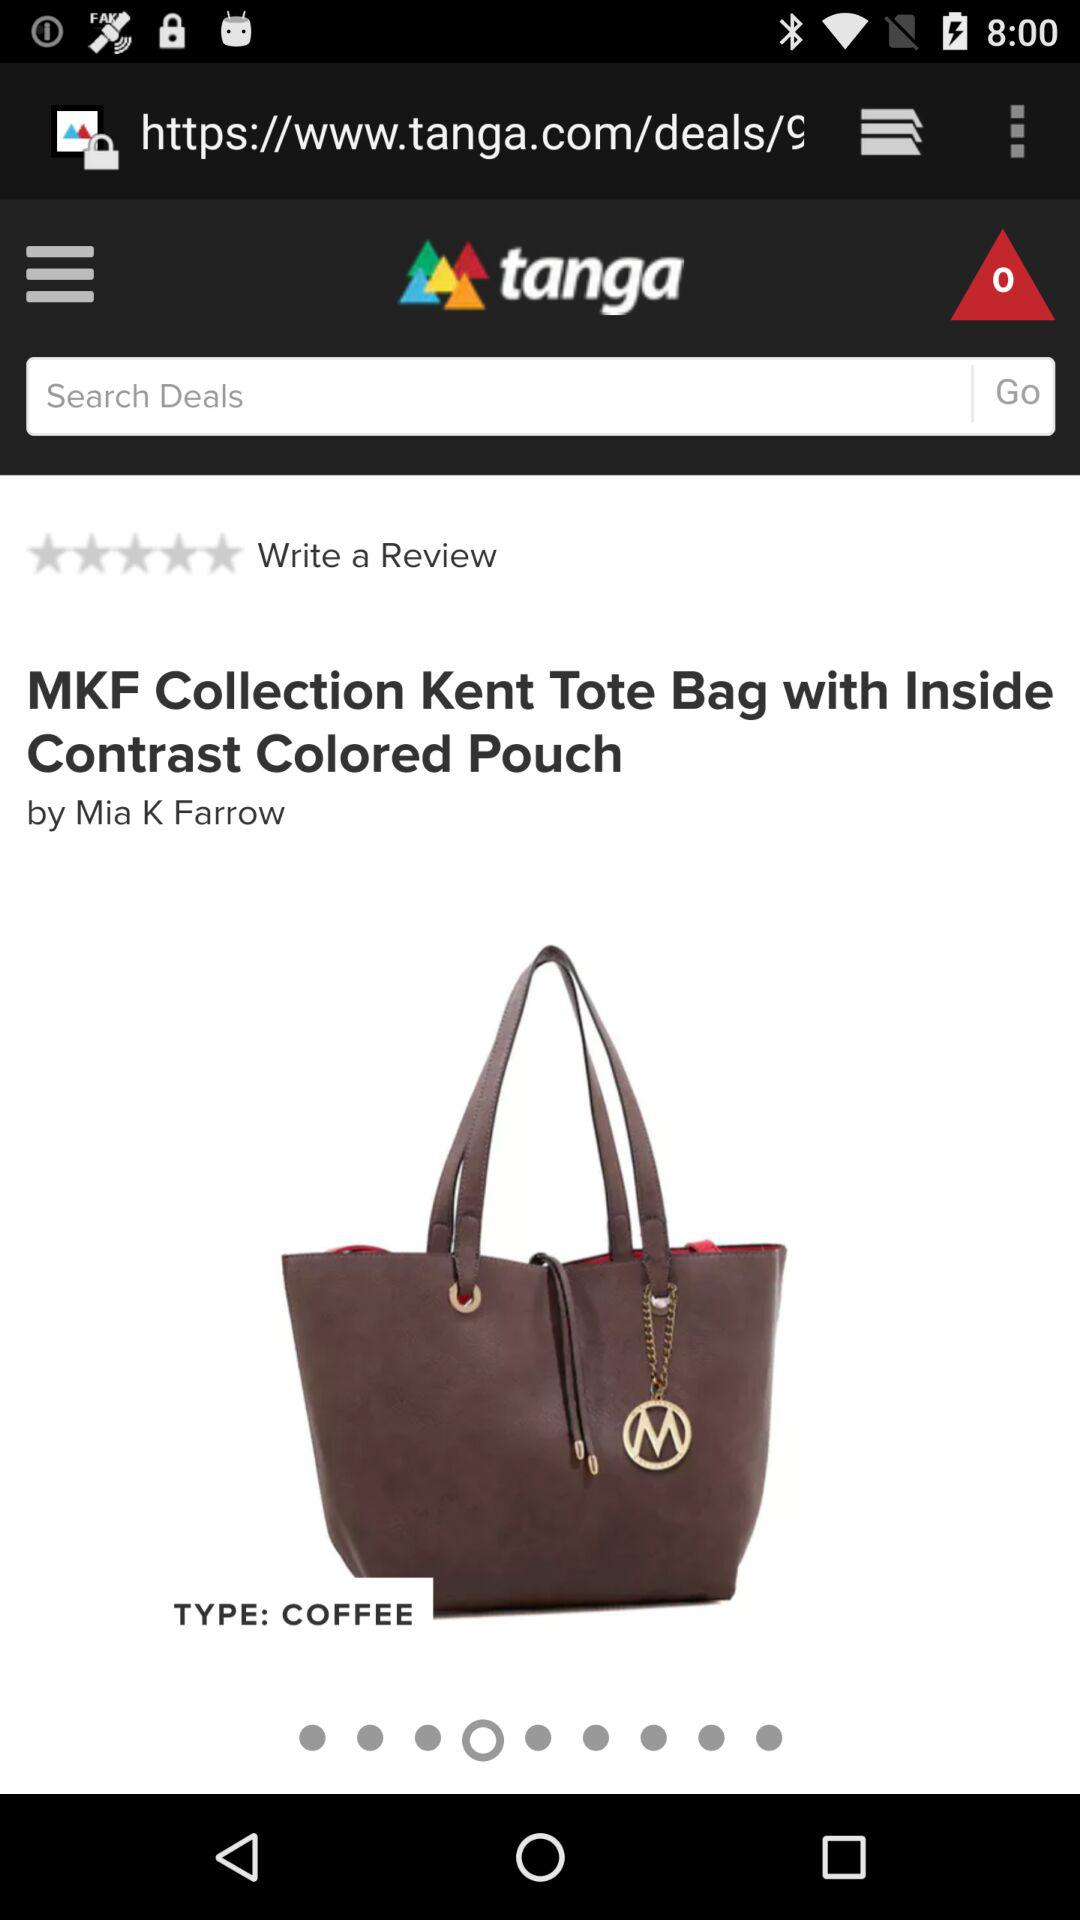What is the brand name? The brand name is Mia K Farrow. 